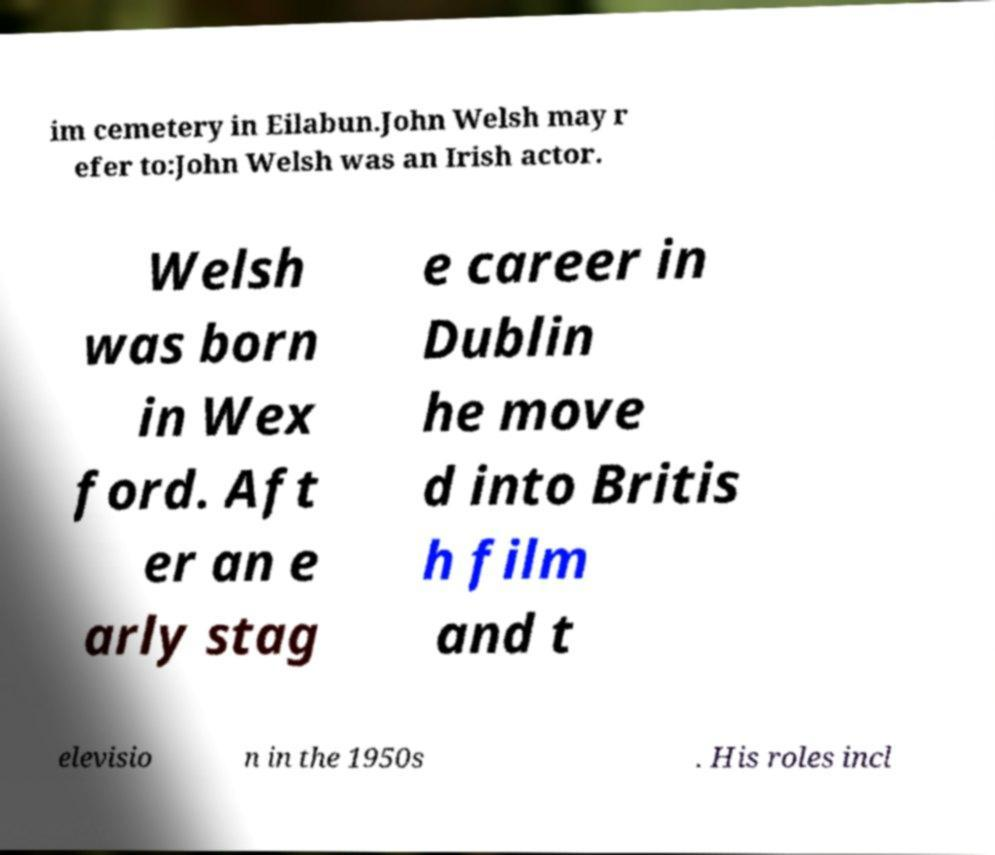I need the written content from this picture converted into text. Can you do that? im cemetery in Eilabun.John Welsh may r efer to:John Welsh was an Irish actor. Welsh was born in Wex ford. Aft er an e arly stag e career in Dublin he move d into Britis h film and t elevisio n in the 1950s . His roles incl 